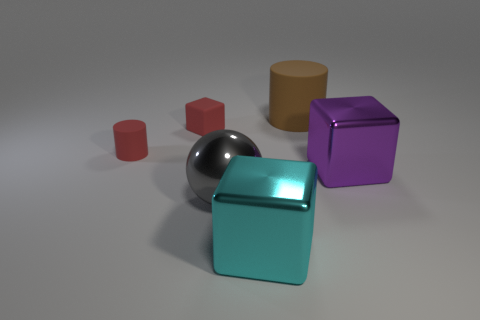Is the color of the metallic block that is behind the large gray metallic sphere the same as the ball?
Your response must be concise. No. There is a cube that is both behind the cyan shiny object and left of the big matte object; what size is it?
Offer a terse response. Small. What number of large things are rubber cylinders or brown rubber cylinders?
Your response must be concise. 1. There is a big rubber thing that is behind the big gray shiny sphere; what shape is it?
Give a very brief answer. Cylinder. What number of small green metal spheres are there?
Keep it short and to the point. 0. Are the small cylinder and the purple cube made of the same material?
Provide a short and direct response. No. Is the number of small rubber things right of the tiny red cube greater than the number of large rubber cylinders?
Your answer should be very brief. No. How many things are either big red matte spheres or metallic objects on the right side of the large brown rubber cylinder?
Your answer should be compact. 1. Is the number of large matte things on the right side of the large cyan cube greater than the number of large purple metallic blocks in front of the metallic ball?
Provide a succinct answer. Yes. The cylinder left of the cube that is in front of the big shiny cube on the right side of the big cyan shiny block is made of what material?
Provide a short and direct response. Rubber. 